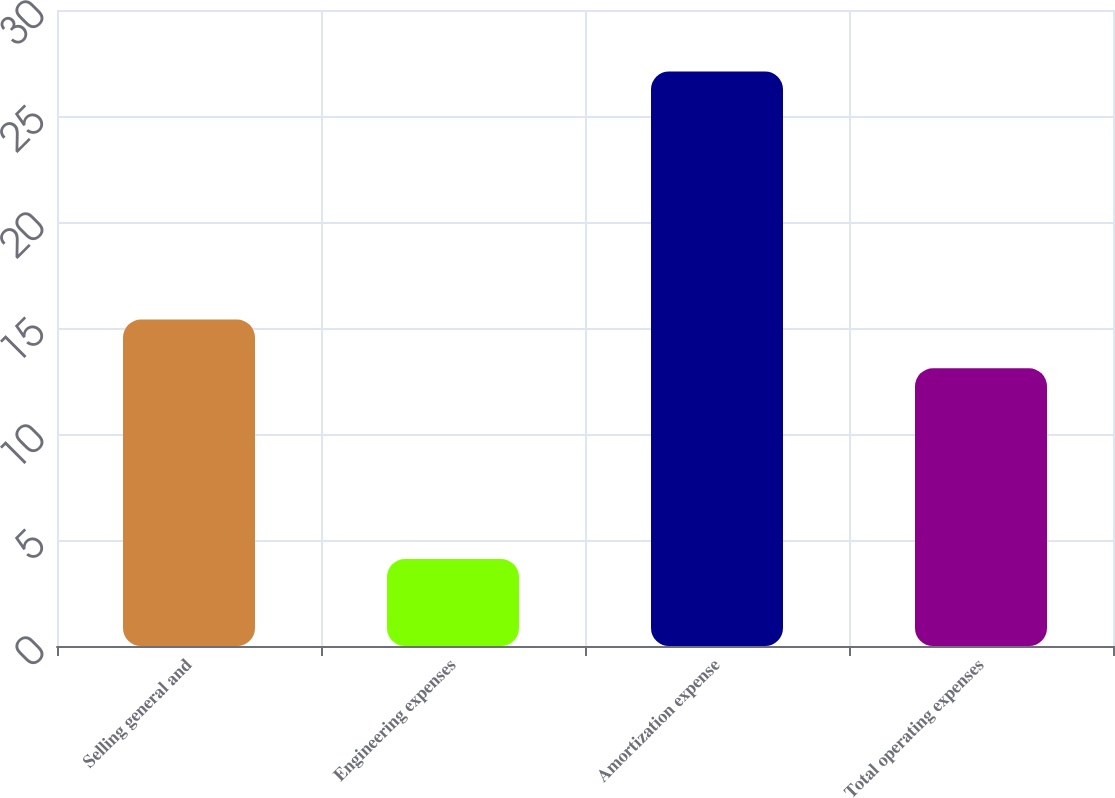Convert chart to OTSL. <chart><loc_0><loc_0><loc_500><loc_500><bar_chart><fcel>Selling general and<fcel>Engineering expenses<fcel>Amortization expense<fcel>Total operating expenses<nl><fcel>15.4<fcel>4.1<fcel>27.1<fcel>13.1<nl></chart> 